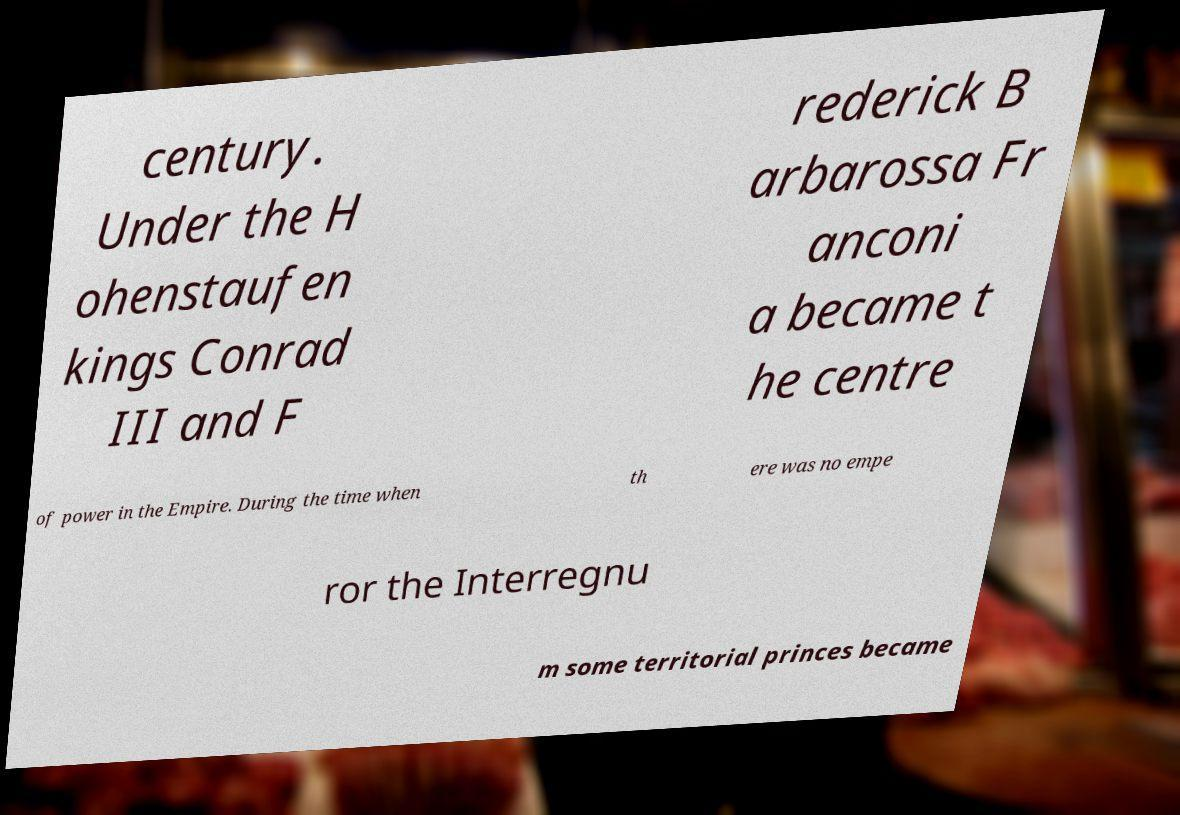There's text embedded in this image that I need extracted. Can you transcribe it verbatim? century. Under the H ohenstaufen kings Conrad III and F rederick B arbarossa Fr anconi a became t he centre of power in the Empire. During the time when th ere was no empe ror the Interregnu m some territorial princes became 